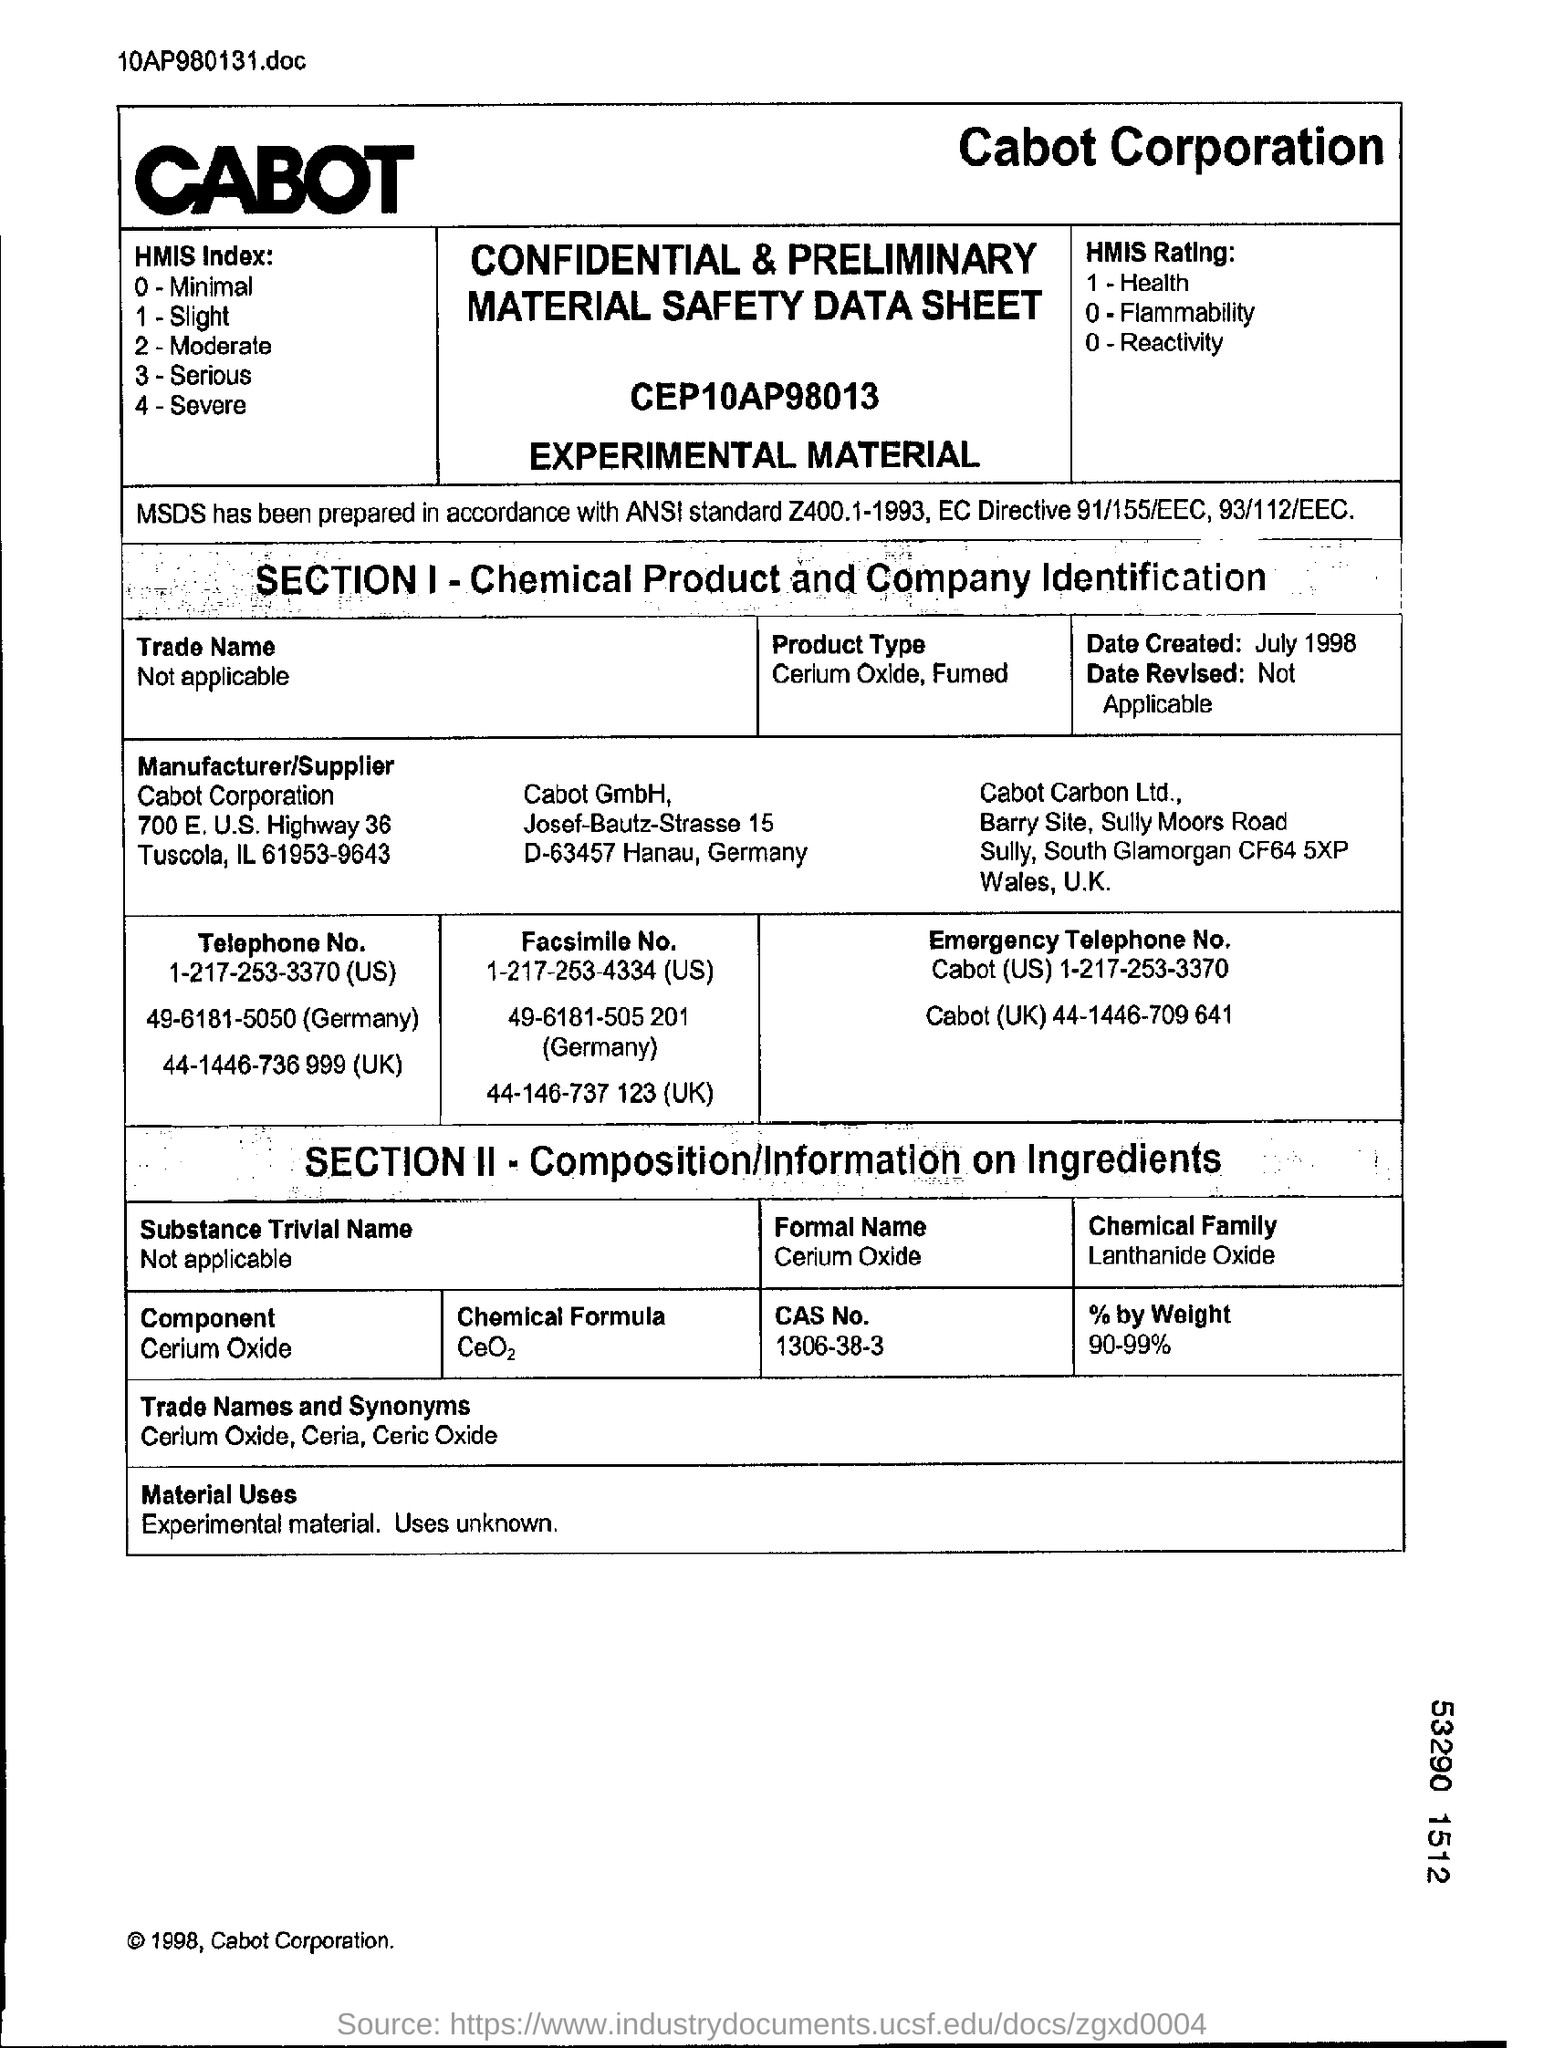What is the component mentioned in section 2?
Make the answer very short. Cerium oxide. What is the chemical formula of cerium oxide?
Your answer should be compact. CeO2. What is the emergency telephone number of Cabot in UK?
Offer a very short reply. 44-1446-709 641. 